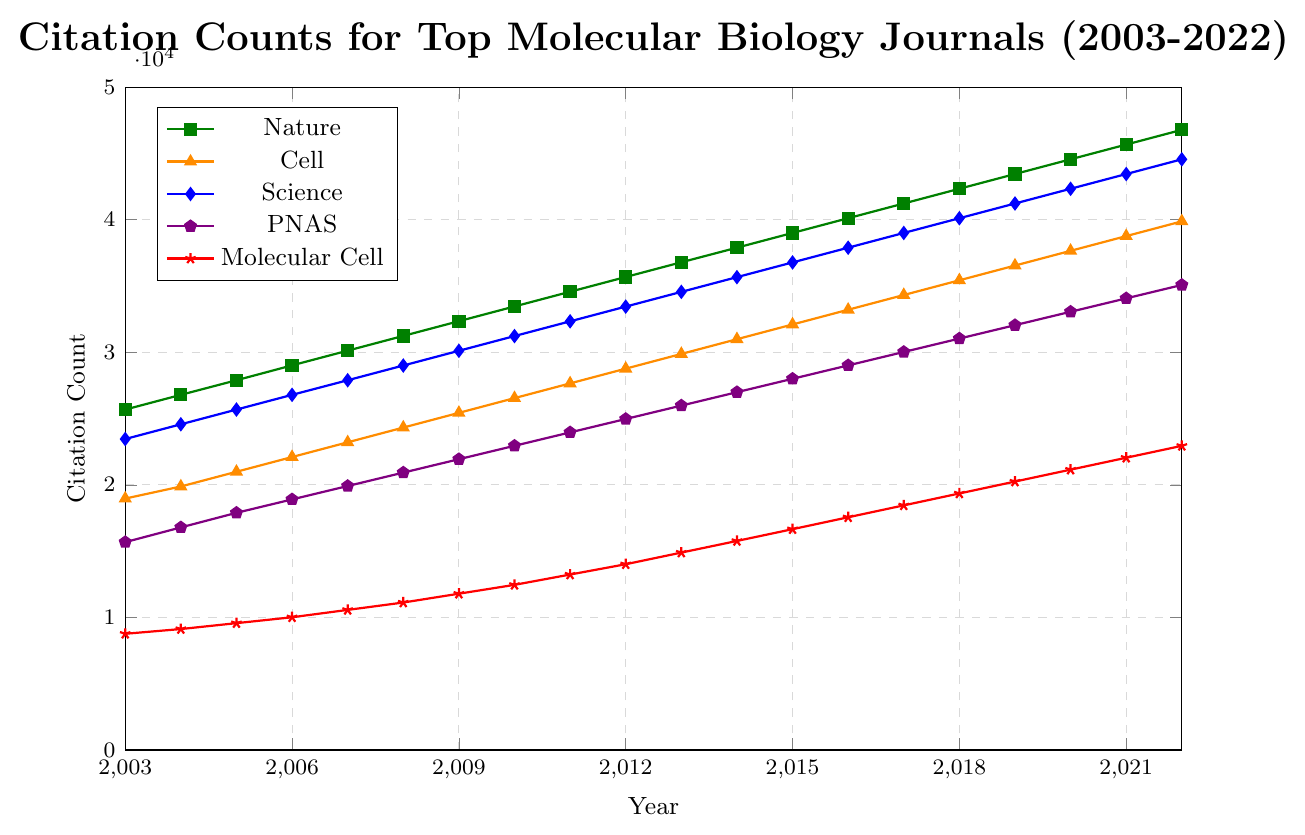Which journal had the highest citation count in 2022? Look at the endpoint of all the lines in the year 2022 and identify the line reaching the highest value on the y-axis. The line representing "Nature" reaches the highest citation count.
Answer: Nature Which journal had the lowest citation count in 2003? Check the beginning of each line on the x-axis corresponding to the year 2003 and find the lowest value. The line representing "Molecular Cell" has the lowest count in 2003.
Answer: Molecular Cell What is the average citation count of PNAS from 2003 to 2007? Identify the citation counts for PNAS from 2003 to 2007: 15678, 16789, 17890, 18901, 19912. Sum these values and divide by 5. (15678 + 16789 + 17890 + 18901 + 19912) = 89170; 89170 / 5 = 17834.
Answer: 17834 By how much did 'Molecular Cell's citation count increase from 2010 to 2022? Identify the citation count of Molecular Cell in 2010 and 2022, which are 12456 and 22942 respectively. Subtract the 2010 count from the 2022 count to find the increase: 22942 - 12456 = 10486.
Answer: 10486 What is the overall trend of citation counts for "Nature" from 2003 to 2022? Observe the line representing "Nature" from 2003 to 2022. The line shows a consistent upward trend.
Answer: Upward trend Compare the citation counts of "Cell" and "Science" in 2015. Which one has a higher count and by how much? Identify the citation counts of Cell and Science in 2015, which are 32097 for Cell and 36778 for Science. Subtract the Cell count from the Science count to find the difference: 36778 - 32097 = 4681.
Answer: Science by 4681 Which journal experienced the most significant increase in citation counts from 2003 to 2022? Calculate the increase for each journal by subtracting the 2003 count from the 2022 count. Nature: 46778 - 25678 = 21100, Cell: 39874 - 18965 = 20909, Science: 44555 - 23456 = 21099, PNAS: 35077 - 15678 = 19399, Molecular Cell: 22942 - 8765 = 14177. Nature experienced the highest increase.
Answer: Nature In which year did "PNAS" surpass 30000 citation counts for the first time? Follow the line representing "PNAS" until it crosses the 30000 mark on the y-axis. This occurs between 2016 and 2017. In 2017, it reaches 30022.
Answer: 2017 